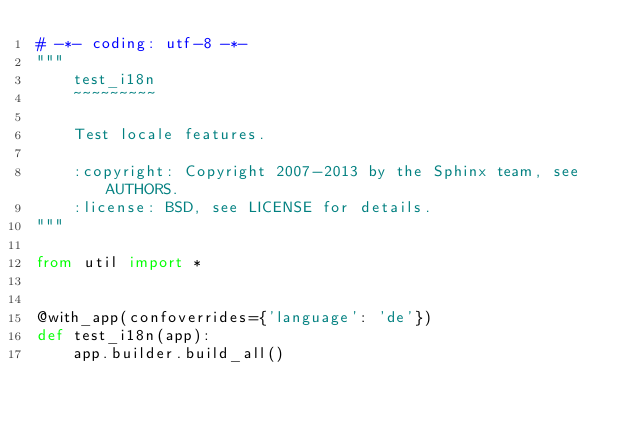Convert code to text. <code><loc_0><loc_0><loc_500><loc_500><_Python_># -*- coding: utf-8 -*-
"""
    test_i18n
    ~~~~~~~~~

    Test locale features.

    :copyright: Copyright 2007-2013 by the Sphinx team, see AUTHORS.
    :license: BSD, see LICENSE for details.
"""

from util import *


@with_app(confoverrides={'language': 'de'})
def test_i18n(app):
    app.builder.build_all()
</code> 